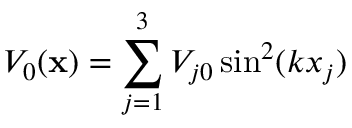<formula> <loc_0><loc_0><loc_500><loc_500>V _ { 0 } ( x ) = \sum _ { j = 1 } ^ { 3 } V _ { j 0 } \sin ^ { 2 } ( k x _ { j } )</formula> 